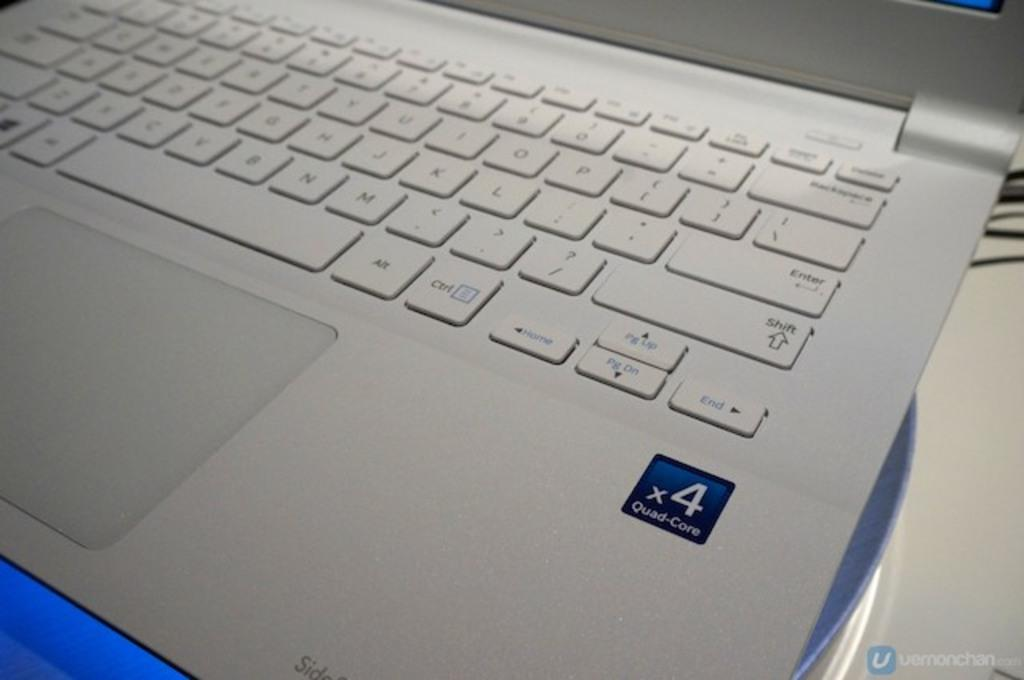<image>
Share a concise interpretation of the image provided. A laptop with a sticker showing it has a x4 Quad core processor. 